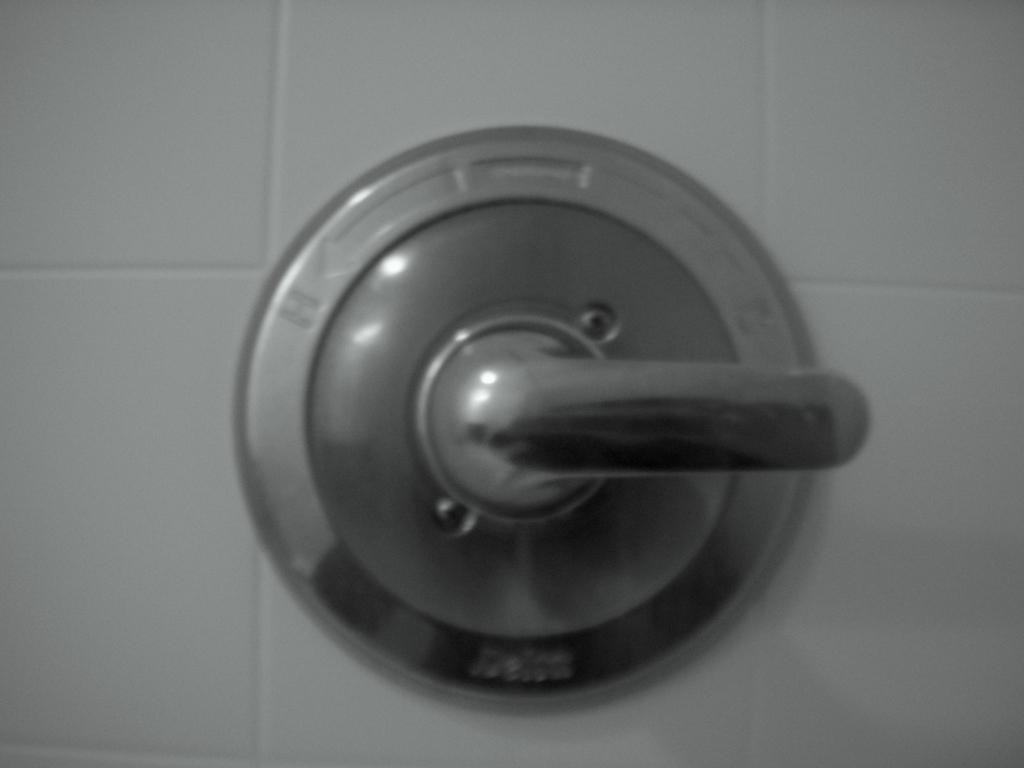What type of material is the object in the image made of? The object in the image is made of metal. Where is the metal object located in the image? The metal object is fixed on the wall. How does the cow feel about the metal object in the image? There is no cow present in the image, so it is not possible to determine how a cow might feel about the metal object. 